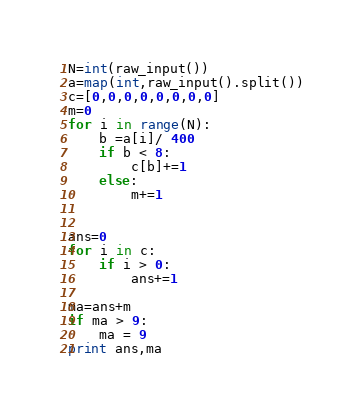<code> <loc_0><loc_0><loc_500><loc_500><_Python_>N=int(raw_input())
a=map(int,raw_input().split())
c=[0,0,0,0,0,0,0,0]
m=0
for i in range(N):
    b =a[i]/ 400
    if b < 8:
        c[b]+=1
    else:
        m+=1


ans=0
for i in c:
    if i > 0:
        ans+=1

ma=ans+m
if ma > 9:
    ma = 9
print ans,ma</code> 